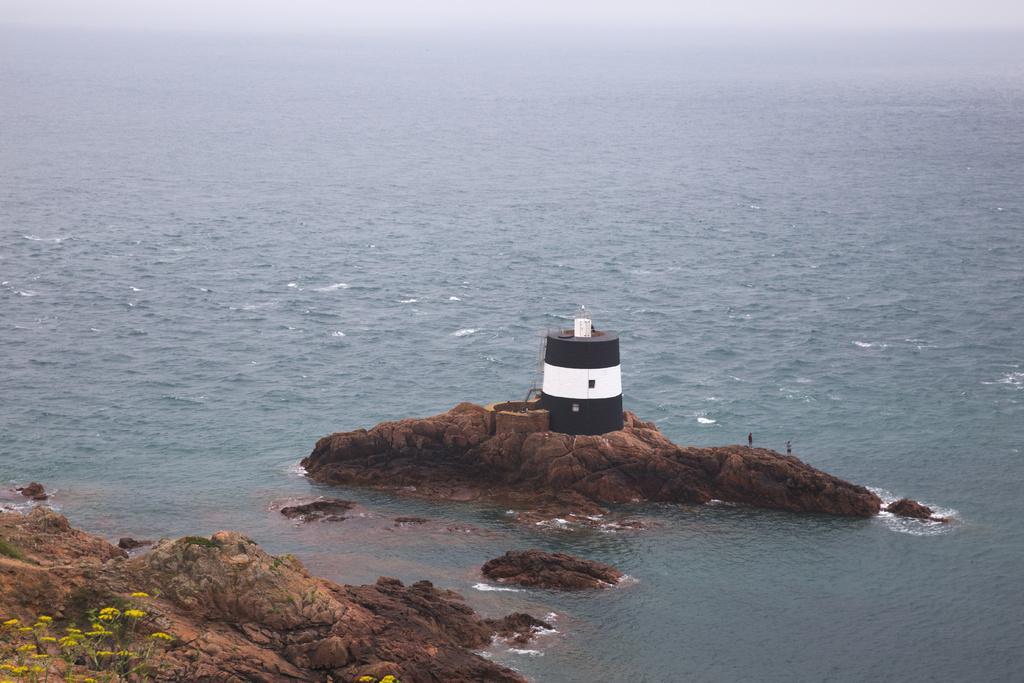Could you give a brief overview of what you see in this image? In this picture we can see rocks, water, plants and flowers. There are two people and we can see light house. 